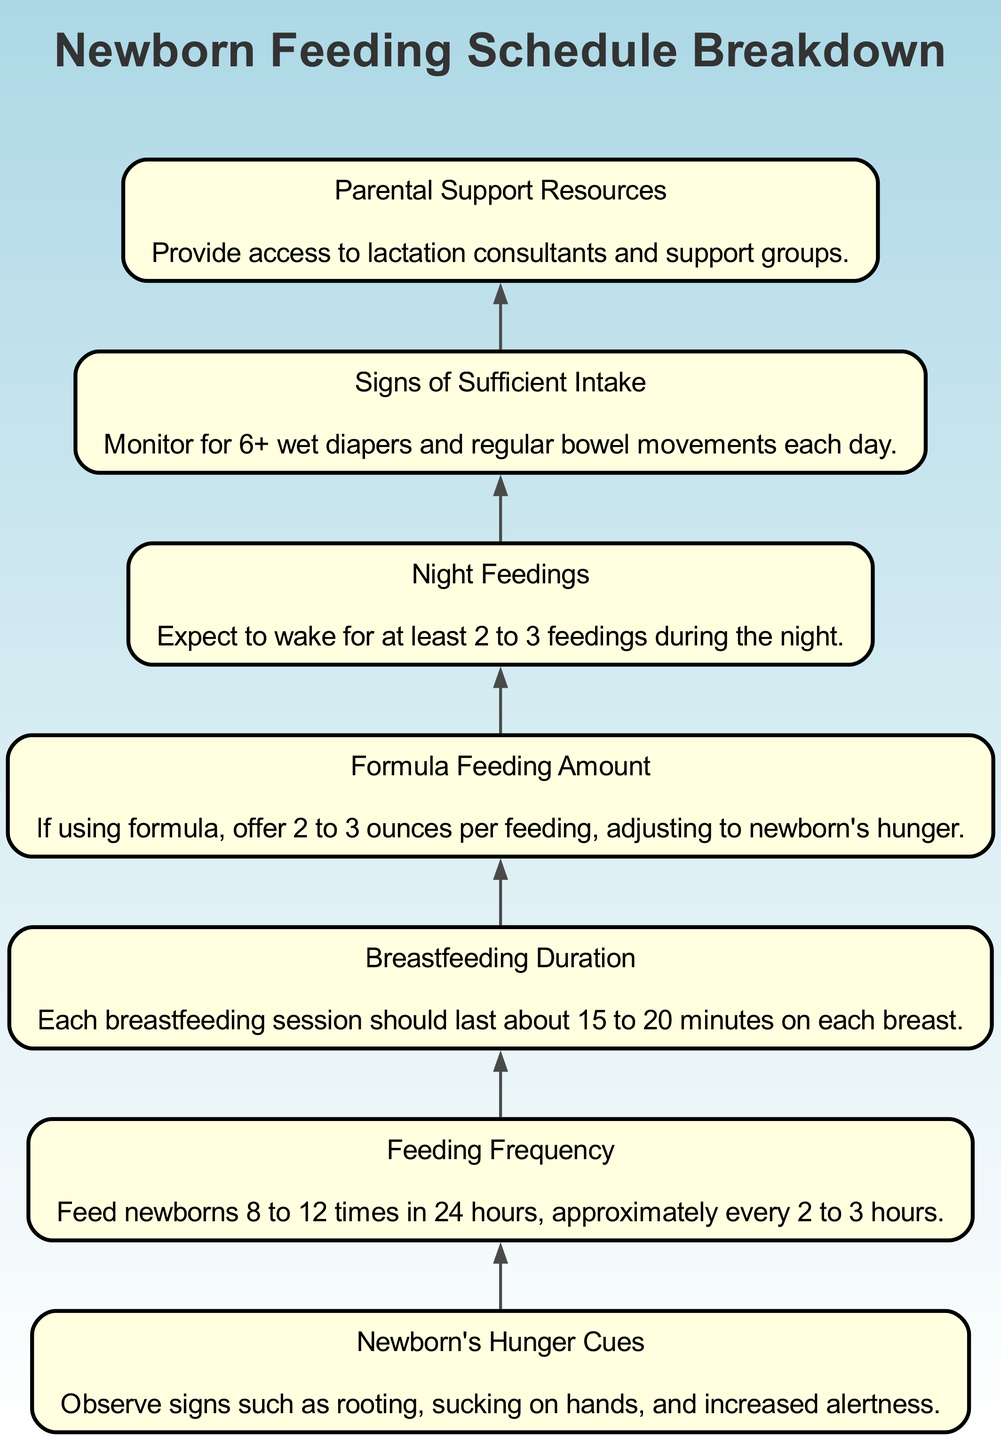What are some signs of hunger in newborns? The diagram indicates that signs of hunger include rooting, sucking on hands, and increased alertness. Therefore, these cues are key indicators for caregivers to observe when a newborn is hungry.
Answer: Rooting, sucking on hands, increased alertness How often should a newborn be fed? According to the diagram, the recommended feeding frequency for newborns is 8 to 12 times in 24 hours, which translates to feeding approximately every 2 to 3 hours.
Answer: 8 to 12 times, every 2 to 3 hours What is the recommended breastfeeding duration for each breast? The diagram specifies that each breastfeeding session should last about 15 to 20 minutes on each breast. This ensures that the newborn receives adequate nutrition.
Answer: 15 to 20 minutes What is the amount of formula to offer if using formula? From the diagram, if using formula, it is recommended to offer 2 to 3 ounces per feeding, letting the newborn's hunger guide adjustments.
Answer: 2 to 3 ounces What is the expected number of night feedings? The diagram suggests expecting at least 2 to 3 feedings during the night as part of the newborn feeding schedule. This is an important aspect of newborn care.
Answer: 2 to 3 feedings What are signs of sufficient intake in a newborn? The diagram highlights that signs of sufficient intake include monitoring for 6 or more wet diapers and regular bowel movements each day, indicating the baby is feeding well.
Answer: 6+ wet diapers, regular bowel movements Does the diagram mention resources for parental support? Yes, the diagram includes a point about providing access to lactation consultants and support groups as parental support resources. This information is vital for new parents.
Answer: Lactation consultants, support groups Why is observing a newborn’s hunger cues important for feeding? Observing a newborn’s hunger cues helps caregivers determine the right time to feed, which ensures the baby is adequately nourished and can promote bonding. This understanding is foundational to the feeding schedule.
Answer: To ensure the baby is adequately nourished How does the feeding frequency relate to newborn's hunger cues? The diagram indicates that newborns should be fed based on hunger cues, which necessitates feeding 8 to 12 times per day, illustrating that the frequency is dependent on recognizing these cues accurately.
Answer: Frequency is dependent on hunger cues 